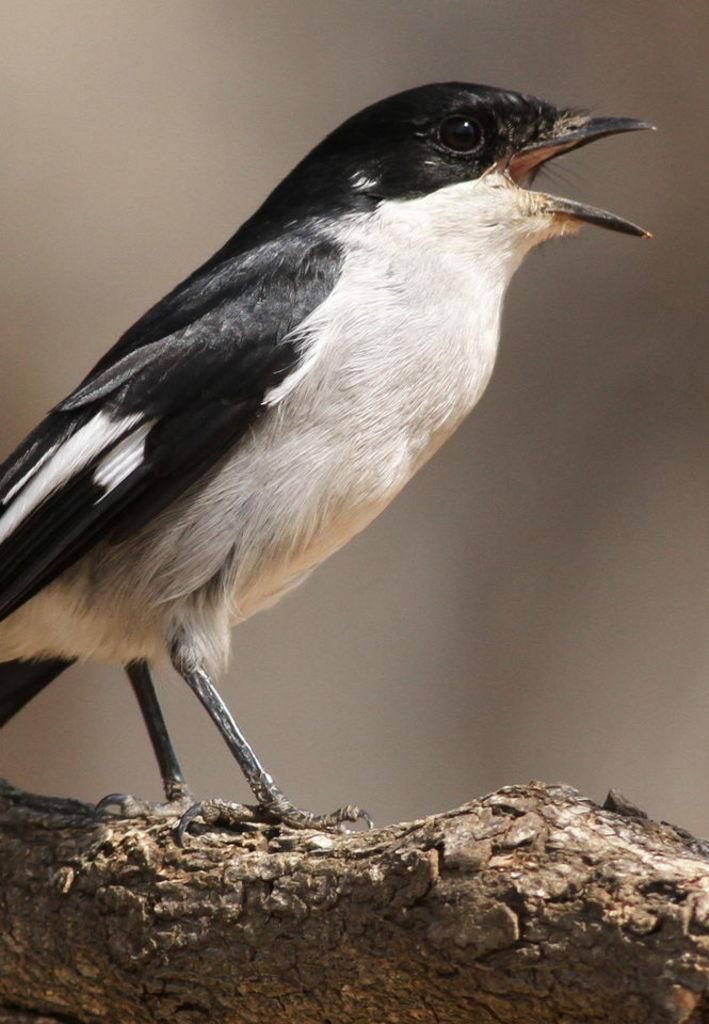What type of animal can be seen in the image? There is a bird in the image. Where is the bird located? The bird is on a branch. Can you describe the background of the image? The background of the image is blurred. What type of bag can be seen hanging from the bird's throat in the image? There is no bag present in the image, nor is there any indication of a bag hanging from the bird's throat. 